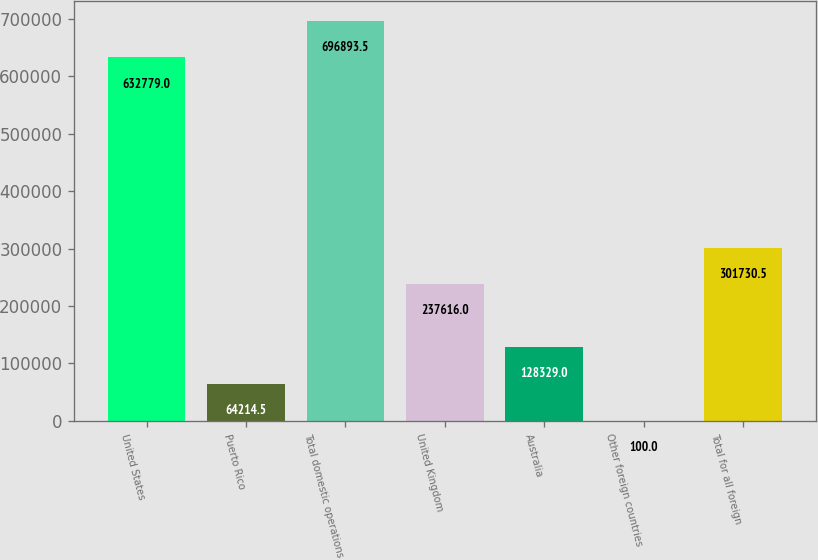Convert chart. <chart><loc_0><loc_0><loc_500><loc_500><bar_chart><fcel>United States<fcel>Puerto Rico<fcel>Total domestic operations<fcel>United Kingdom<fcel>Australia<fcel>Other foreign countries<fcel>Total for all foreign<nl><fcel>632779<fcel>64214.5<fcel>696894<fcel>237616<fcel>128329<fcel>100<fcel>301730<nl></chart> 